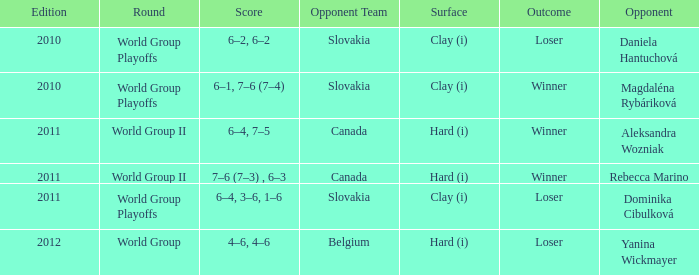What was the score when the opposing team was from Belgium? 4–6, 4–6. 